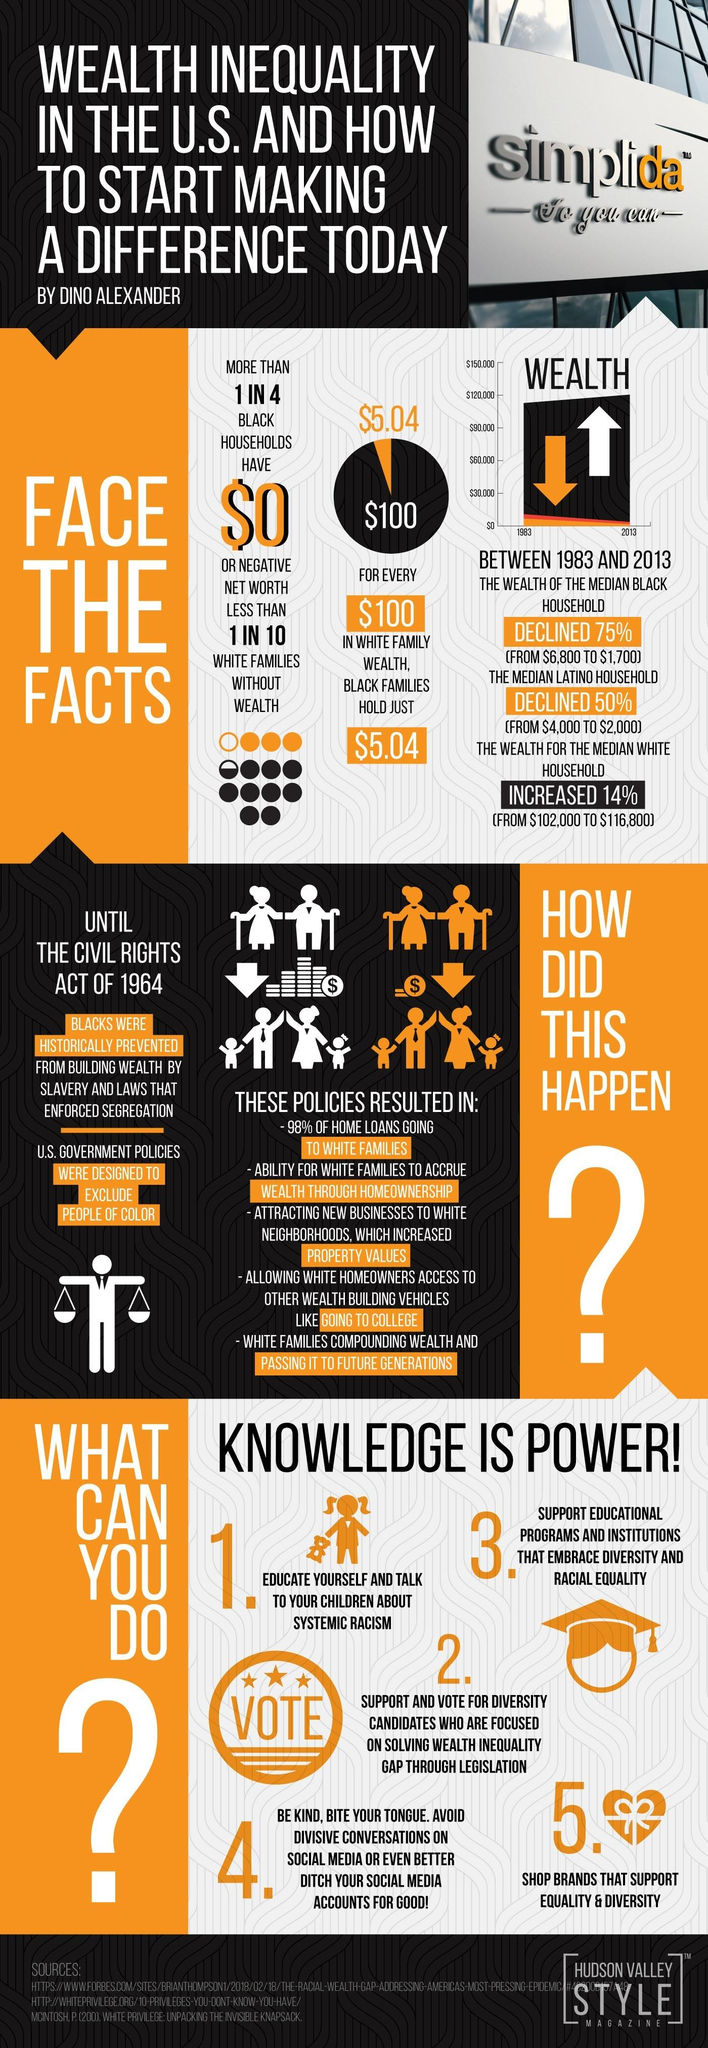Point out several critical features in this image. According to data, only 2% of home loans were going to black families. I have identified five points that outline strategies for reducing color-based discrimination. The U.S. Government policies were crafted to exclude people of color, reflecting a peculiarity in their design. The wealth of Black families is significantly lower when compared to white families, with a difference of $5.04. 